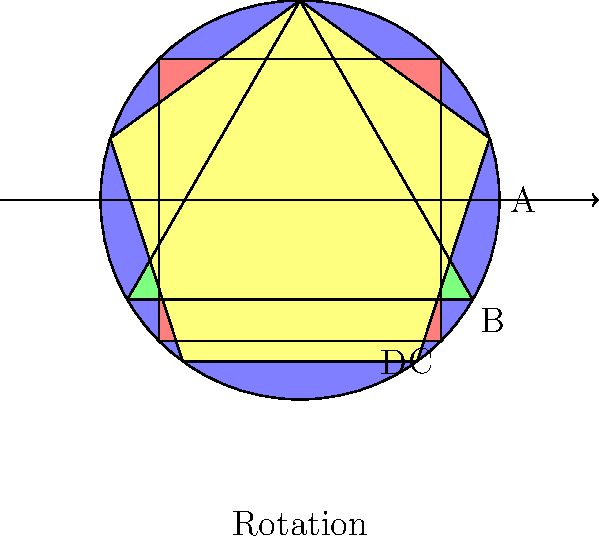You're designing a new baby mobile for your latest product endorsement, featuring four different shapes: a circle (A), triangle (B), square (C), and pentagon (D). The mobile rotates clockwise, moving each shape to the next position. How many rotations are needed before all shapes return to their original positions, forming a cyclic group? To solve this problem, we need to understand the concept of cyclic groups and least common multiple (LCM):

1. Each shape returns to its original position after a certain number of rotations:
   - Circle (A): 4 rotations
   - Triangle (B): 4 rotations
   - Square (C): 4 rotations
   - Pentagon (D): 4 rotations

2. The number of rotations needed for all shapes to return to their original positions simultaneously is the LCM of these individual rotation counts.

3. In this case, all shapes return to their original positions after 4 rotations, so the LCM is simply 4.

4. This forms a cyclic group of order 4, which can be represented as $C_4$ or $\mathbb{Z}_4$.

5. The group elements can be thought of as the rotations: $\{e, r, r^2, r^3\}$, where $e$ is the identity (no rotation) and $r$ is a single clockwise rotation.

6. The group operation is composition of rotations, and each element generates the entire group.

Therefore, the cyclic group structure of this baby mobile has order 4, requiring 4 rotations to return to the initial configuration.
Answer: 4 rotations ($C_4$ or $\mathbb{Z}_4$) 